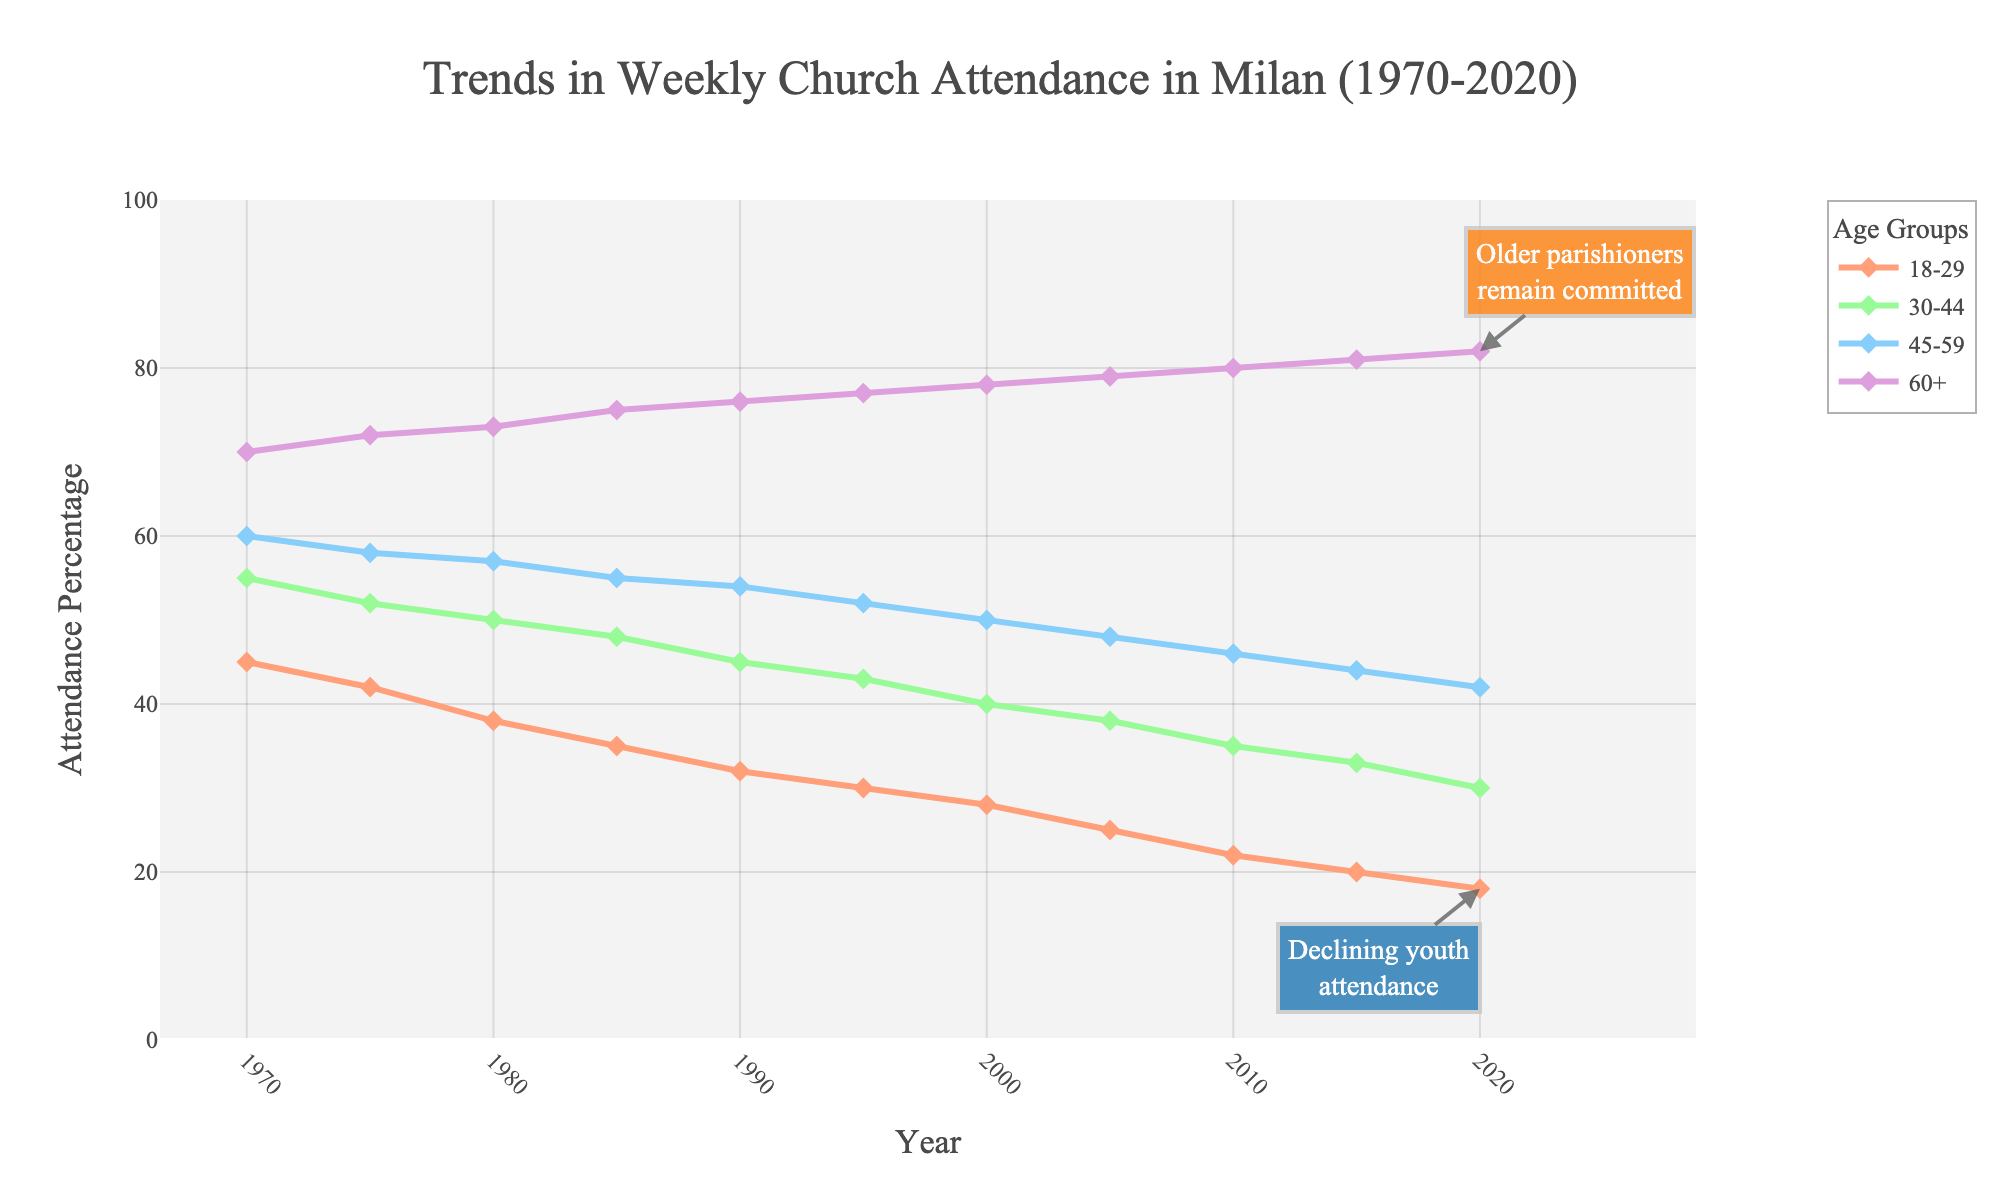What is the general trend in weekly church attendance for the 18-29 age group? The weekly church attendance for the 18-29 age group shows a consistent decline over the past 50 years, starting from 45% in 1970 to 18% in 2020.
Answer: A consistent decline How does the attendance of older parishioners (60+) in 2020 compare to that in 1970? In 1970, the attendance for the 60+ age group was 70%, and in 2020, it is 82%. The attendance has increased over the span of 50 years by 12 percentage points.
Answer: Increased by 12 percentage points Which age group had the highest attendance in 2010? To find this, look at the lines on the chart for the year 2010. The 60+ age group had the highest attendance at 80%.
Answer: 60+ What is the difference in attendance between the 45-59 and 18-29 age groups in 1990? In 1990, the attendance for the 45-59 age group was 54%, and for the 18-29 age group, it was 32%. The difference is 54% - 32% = 22%.
Answer: 22% What year did the 30-44 age group experience the steepest drop in attendance? To determine the steepest drop, observe the steepness of the decline in the line for the 30-44 age group. The steepest drop occurred between 1980 and 1985, from 50% to 48%.
Answer: Between 1980 and 1985 On average, which age group had the highest weekly church attendance from 1970 to 2020? Calculate the average attendance for each age group over the 50 years. The 60+ age group consistently had the highest attendance, averaging higher percentages compared to the other groups.
Answer: 60+ By how much did the attendance of the 30-44 age group decrease from 1970 to 2020? In 1970, the attendance for the 30-44 age group was 55%, and it decreased to 30% in 2020. The decrease is 55% - 30% = 25%.
Answer: 25% How does the color coding help in differentiating the age groups in the chart? The use of different colors for each age group makes it easy to visually distinguish between the groups: peach for 18-29, light green for 30-44, light blue for 45-59, and lavender for 60+. This aids in quick identification.
Answer: Different colors help distinguish age groups Which age group had the smallest decline in attendance from 1970 to 2020? Look at the overall decline for each age group. The 60+ age group experienced the smallest decline, as their attendance actually increased from 70% in 1970 to 82% in 2020.
Answer: 60+ During which decade did the 18-29 age group see the largest decrease in weekly church attendance? To find the largest decrease, compare the decline over each decade. The largest decrease for the 18-29 age group was during the 1970s, from 45% in 1970 to 42% in 1975 (a 3 percentage point drop).
Answer: 1970s 